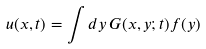Convert formula to latex. <formula><loc_0><loc_0><loc_500><loc_500>u ( x , t ) = \int d y \, G ( x , y ; t ) f ( y )</formula> 